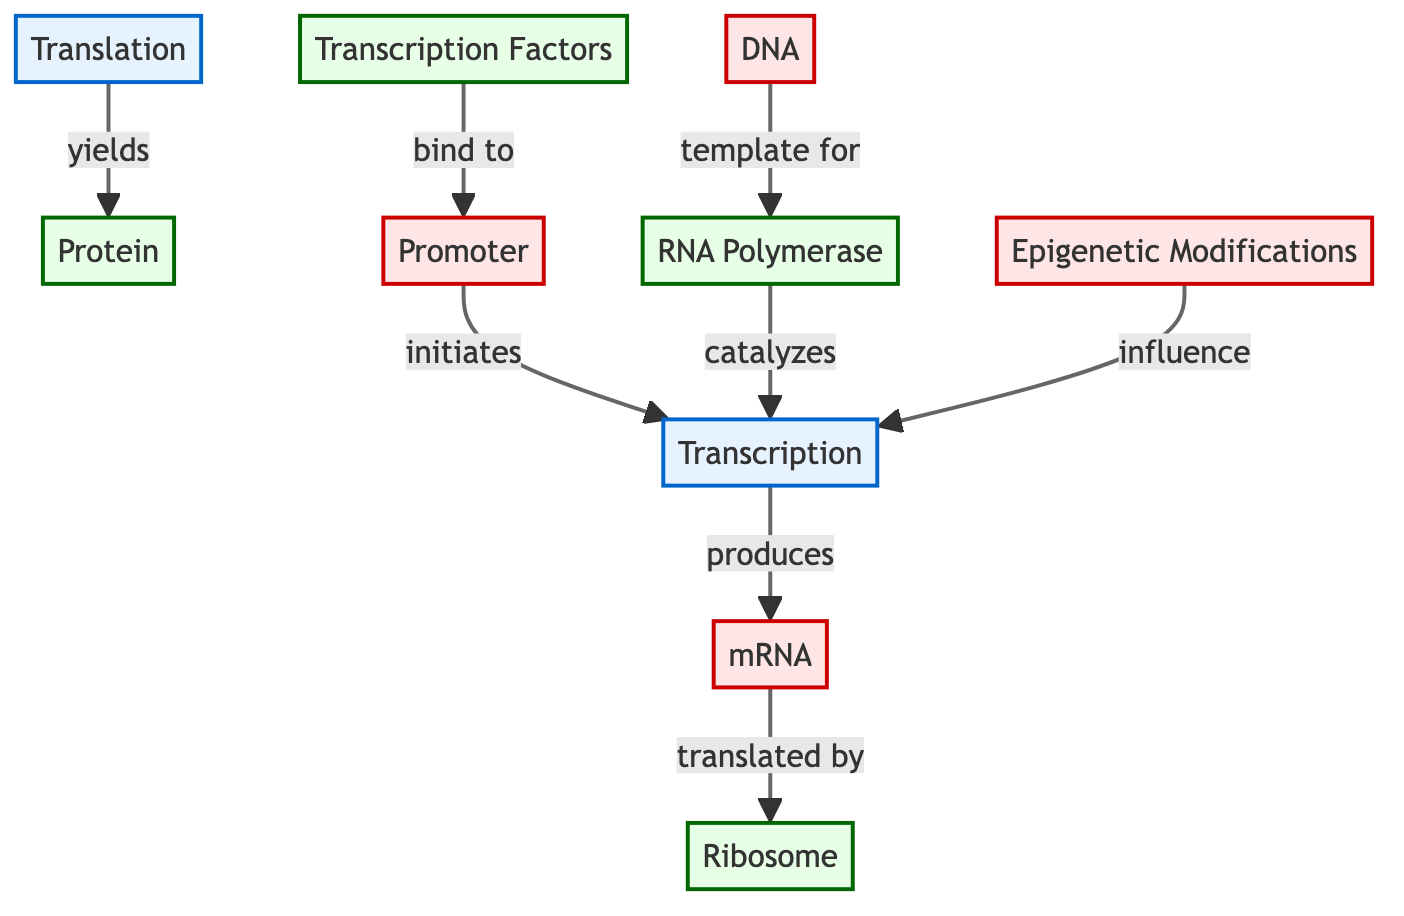What initiates the transcription process? The diagram shows an arrow from the promoter to transcription, labeled "initiates". This indicates that the promoter is the element that starts the transcription process.
Answer: Promoter How many proteins are involved in the gene expression process? In the diagram, there are three distinct protein nodes: transcription factors, RNA polymerase, and ribosome. Thus, the total number of proteins involved is three.
Answer: 3 What is produced by transcription? According to the diagram, there is an arrow connecting transcription to mRNA, labeled "produces". This clearly indicates that mRNA is the output of the transcription process.
Answer: mRNA Which molecular process follows the production of mRNA? The diagram shows an arrow from mRNA to translation, indicating that the next step after mRNA production is translation. Thus, translation is the process that follows mRNA.
Answer: Translation How do epigenetic modifications affect transcription? The diagram demonstrates that epigenetic modifications influence transcription, as shown by the arrow labeled "influence". This connection indicates that these modifications play a role in how transcription occurs.
Answer: influence What is the main role of RNA polymerase in this diagram? The diagram indicates that RNA polymerase catalyzes transcription, as shown by the arrow labeled "catalyzes" from RNA polymerase to transcription. This means that RNA polymerase is responsible for facilitating the transcription process.
Answer: catalyzes What results from the translation process? In the diagram, there is an arrow from translation to protein that is labeled "yields". This suggests that the output from the translation process is protein.
Answer: Protein What binds to the promoter during the transcription process? The diagram displays an arrow from transcription factors to the promoter, indicating that transcription factors bind to the promoter to initiate transcription.
Answer: Transcription Factors How does mRNA get translated according to the diagram? The diagram indicates an arrow from mRNA to ribosome labeled "translated by", showing that ribosomes are the entities translating mRNA into protein. Therefore, mRNA is translated by ribosomes.
Answer: Ribosome 